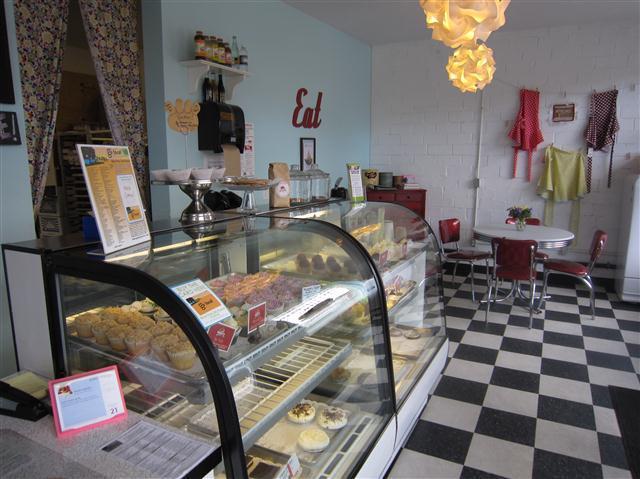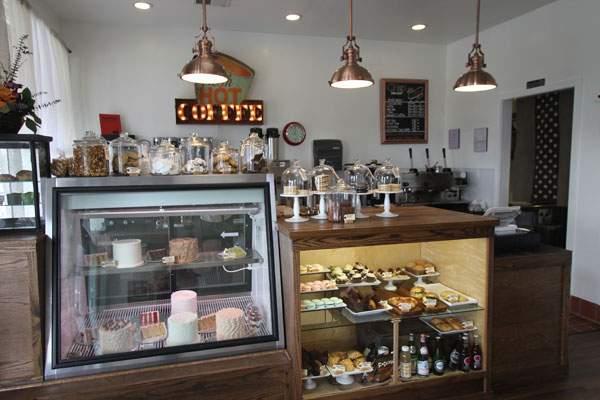The first image is the image on the left, the second image is the image on the right. Analyze the images presented: Is the assertion "The left image is an interior featuring open-back black chairs around at least one white rectangular table on a black-and-white checkered floor." valid? Answer yes or no. No. The first image is the image on the left, the second image is the image on the right. Assess this claim about the two images: "In one image, a bakery has a seating area with black chairs and at least one white table.". Correct or not? Answer yes or no. No. 